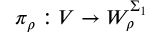<formula> <loc_0><loc_0><loc_500><loc_500>\pi _ { \rho } \colon V \to W _ { \rho } ^ { \Sigma _ { 1 } }</formula> 